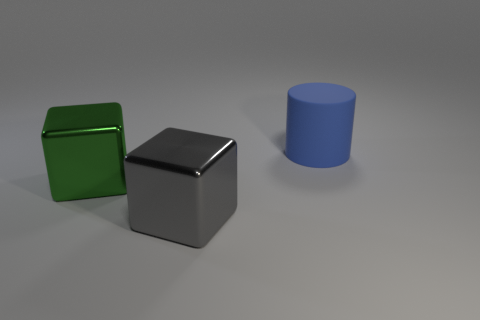Can you estimate the relative sizes of the objects? While exact measurements are not possible, we can make an educated guess. The green and silver cubes appear to be identical in size and roughly have a square face, while the blue cylinder seems to be taller than the cubes but with a smaller diameter. Therefore, it would be reasonable to deduce that the cubes are larger in volume than the cylinder. 